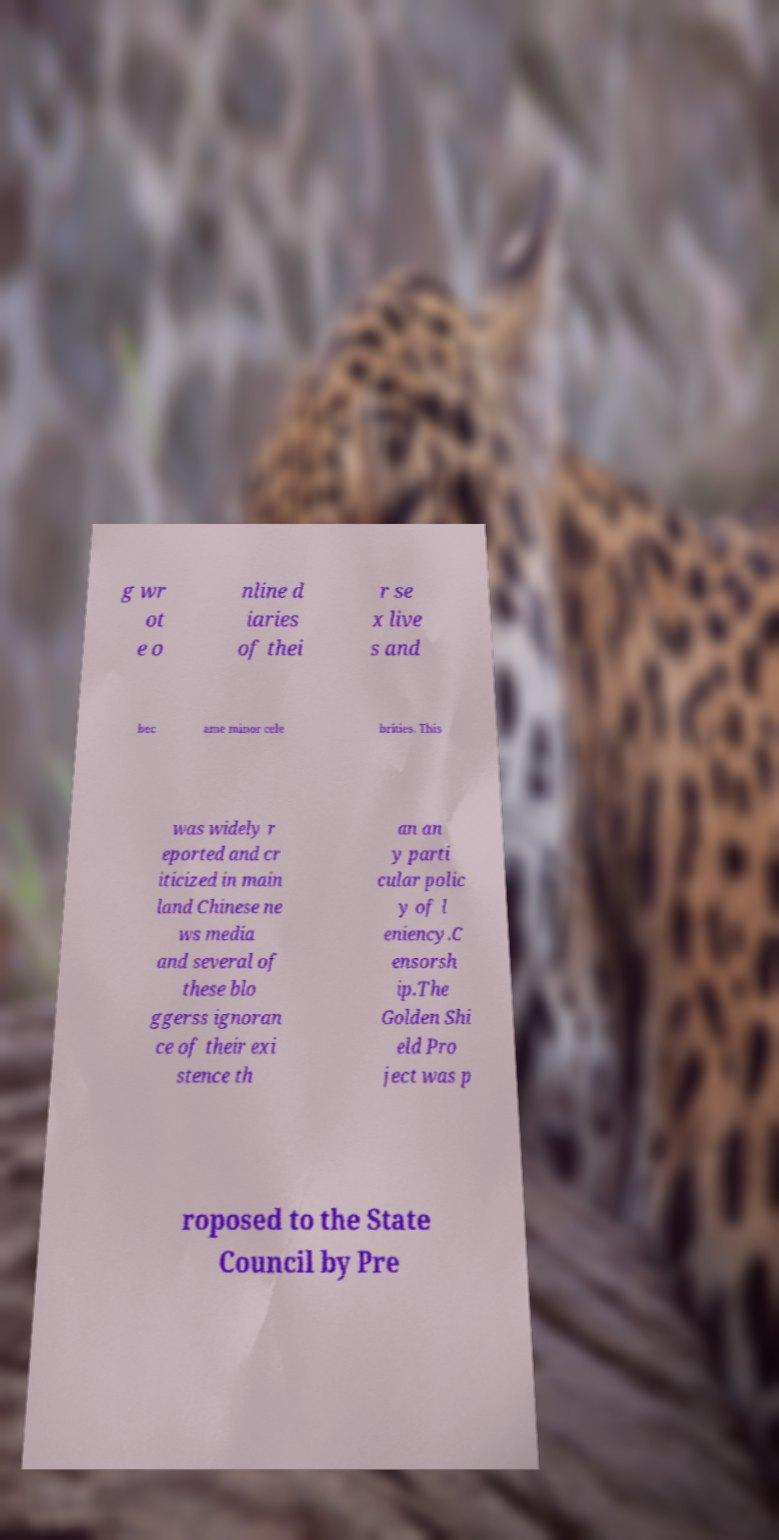Can you read and provide the text displayed in the image?This photo seems to have some interesting text. Can you extract and type it out for me? g wr ot e o nline d iaries of thei r se x live s and bec ame minor cele brities. This was widely r eported and cr iticized in main land Chinese ne ws media and several of these blo ggerss ignoran ce of their exi stence th an an y parti cular polic y of l eniency.C ensorsh ip.The Golden Shi eld Pro ject was p roposed to the State Council by Pre 